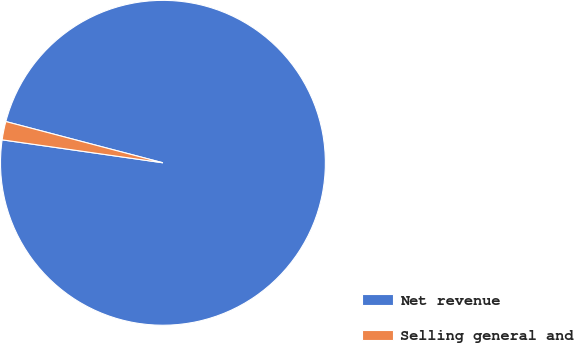<chart> <loc_0><loc_0><loc_500><loc_500><pie_chart><fcel>Net revenue<fcel>Selling general and<nl><fcel>98.17%<fcel>1.83%<nl></chart> 